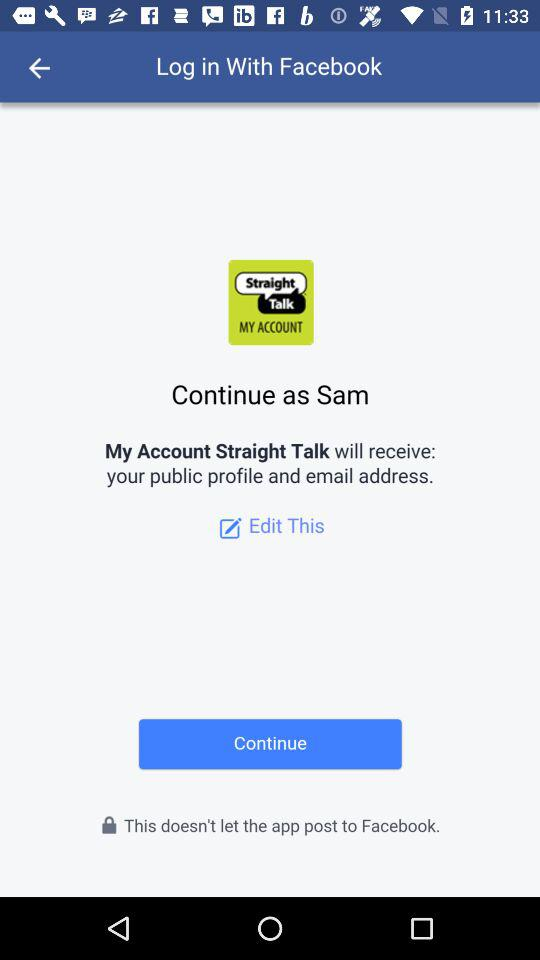What is the name used for logging in on Facebook? The name is Sam. 